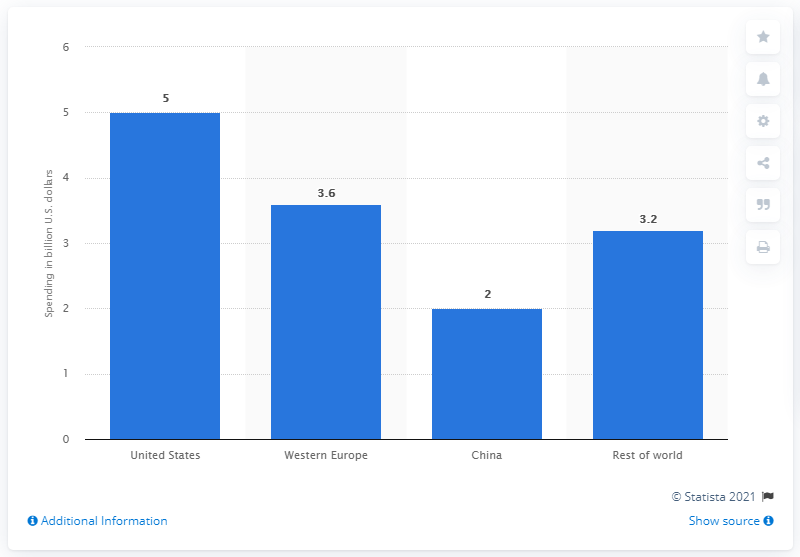Specify some key components in this picture. The projection for U.S. spending on 3D printers in 2019 is expected to be $5. 